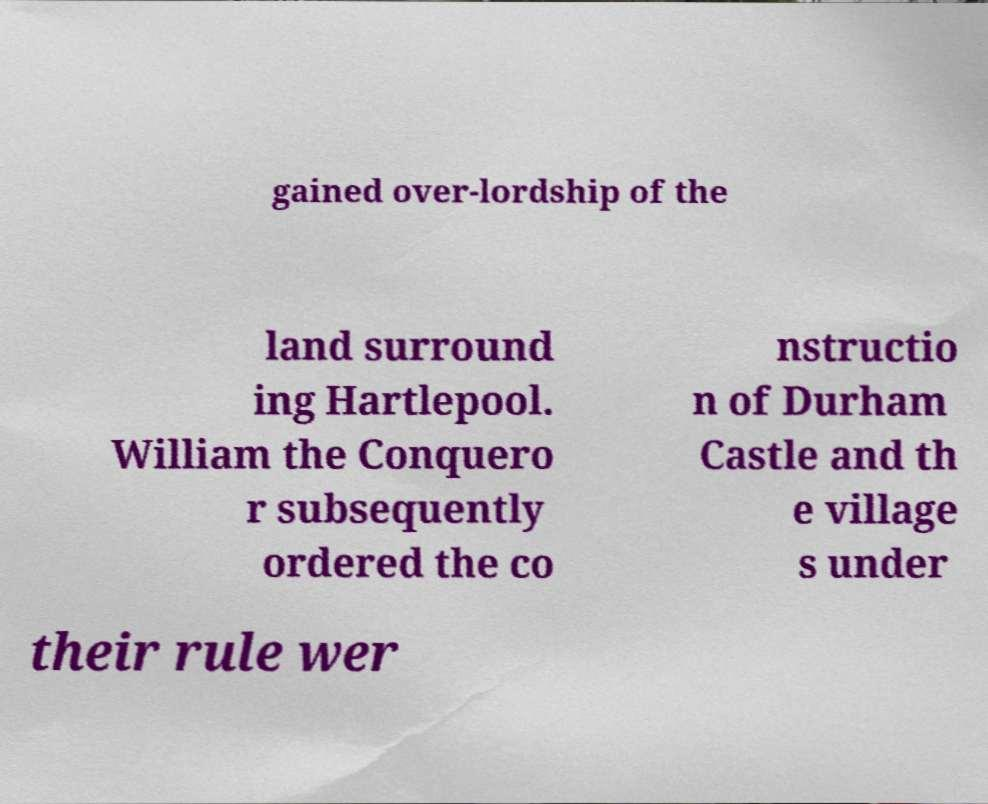I need the written content from this picture converted into text. Can you do that? gained over-lordship of the land surround ing Hartlepool. William the Conquero r subsequently ordered the co nstructio n of Durham Castle and th e village s under their rule wer 